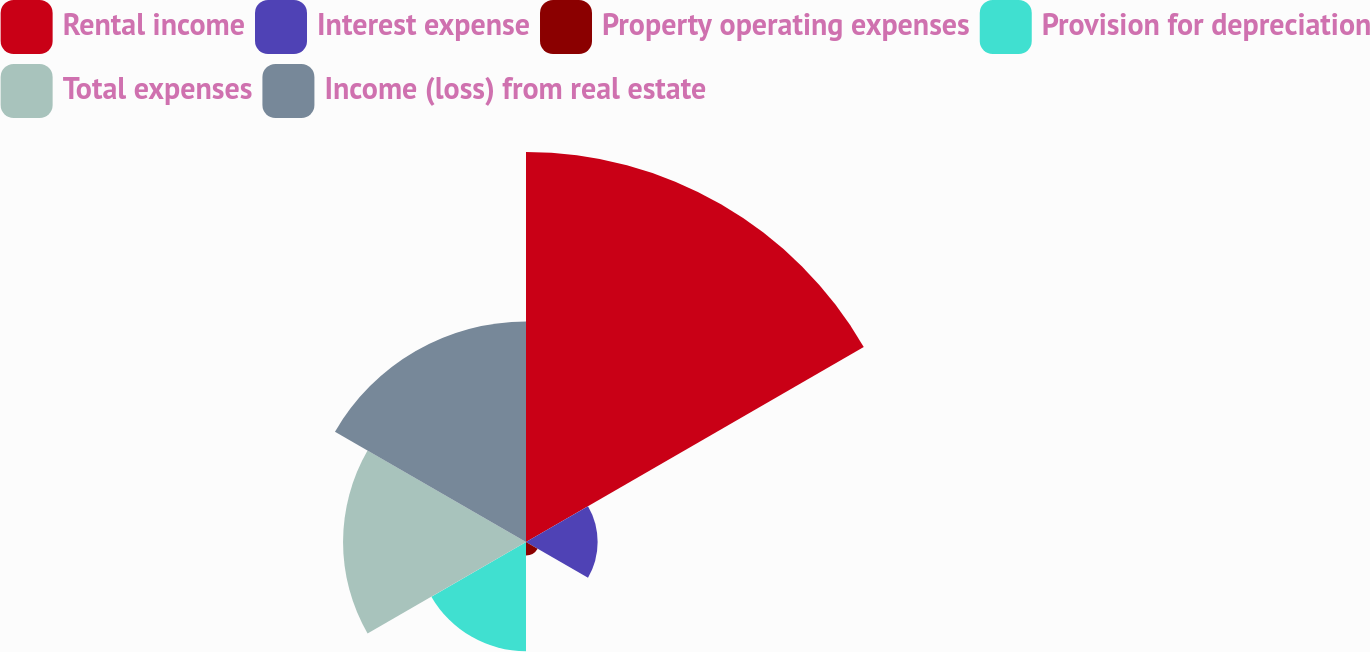<chart> <loc_0><loc_0><loc_500><loc_500><pie_chart><fcel>Rental income<fcel>Interest expense<fcel>Property operating expenses<fcel>Provision for depreciation<fcel>Total expenses<fcel>Income (loss) from real estate<nl><fcel>39.48%<fcel>7.25%<fcel>1.36%<fcel>11.06%<fcel>18.52%<fcel>22.33%<nl></chart> 